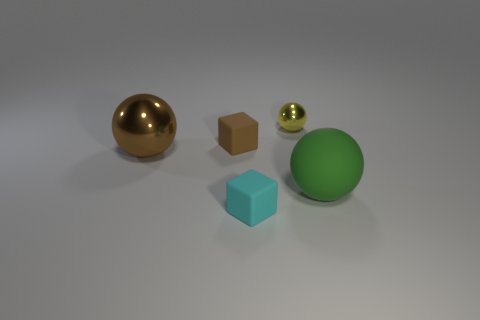Add 3 purple rubber cylinders. How many objects exist? 8 Subtract all blocks. How many objects are left? 3 Subtract all large metal things. Subtract all cyan blocks. How many objects are left? 3 Add 3 tiny rubber things. How many tiny rubber things are left? 5 Add 2 red metallic objects. How many red metallic objects exist? 2 Subtract 0 red cylinders. How many objects are left? 5 